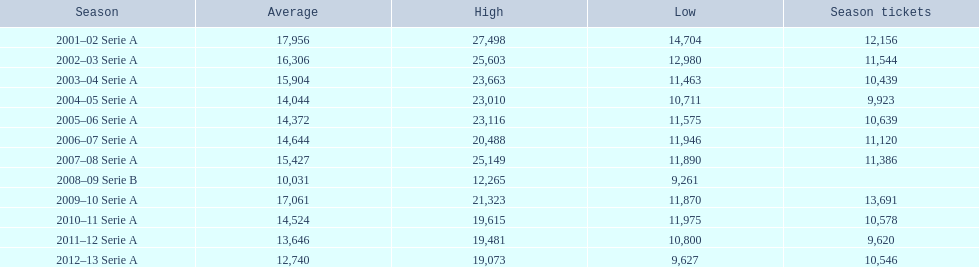What was the mean attendance in 2008? 10,031. 